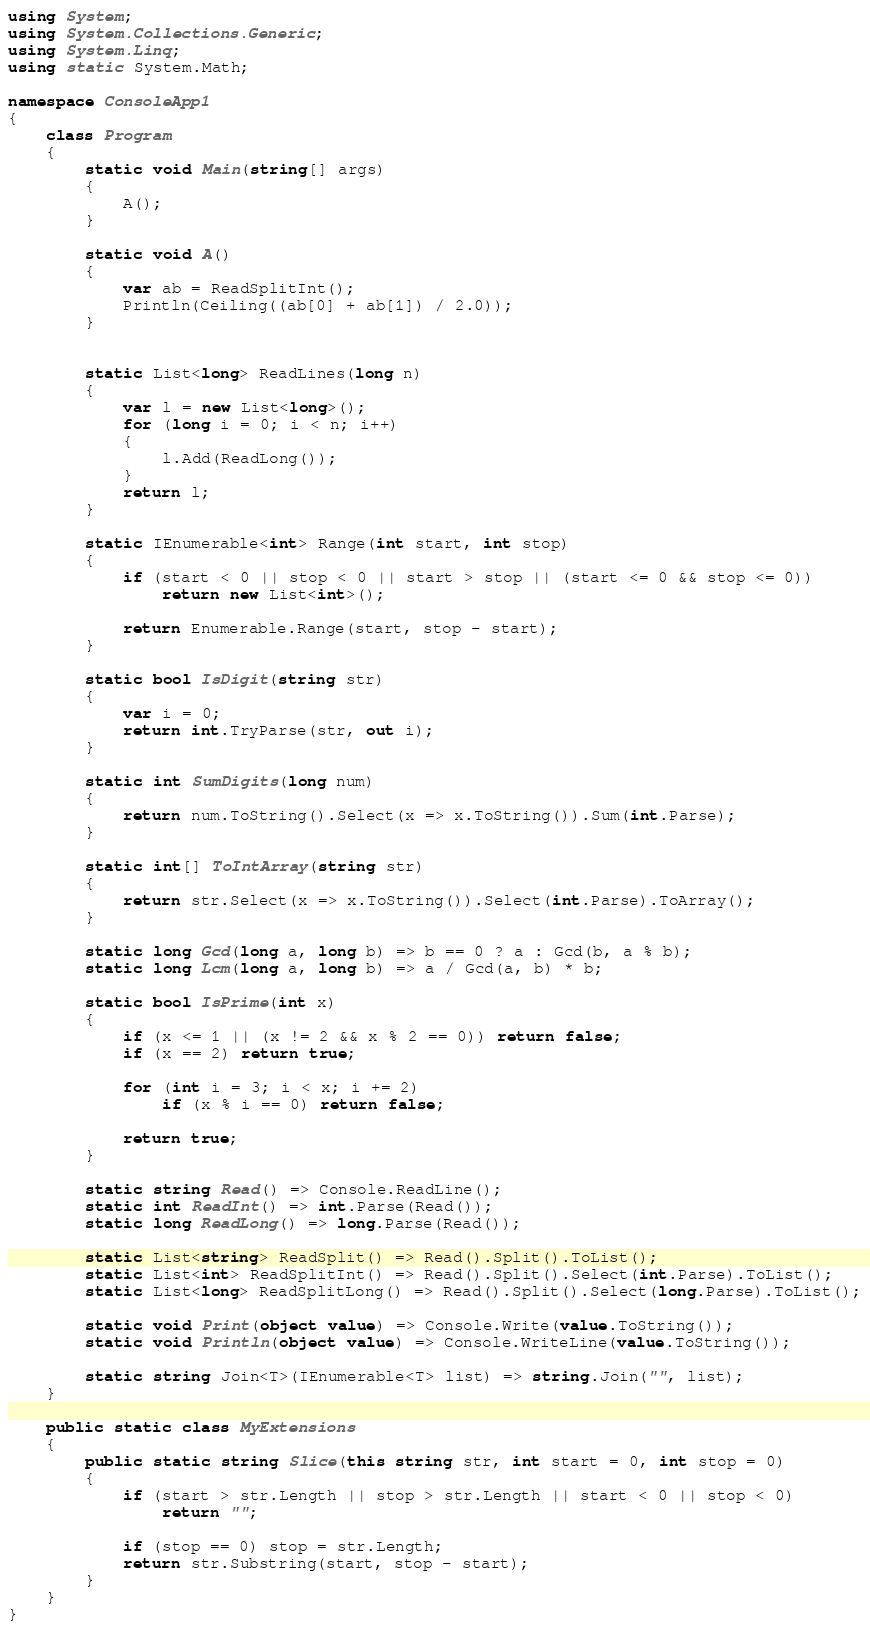<code> <loc_0><loc_0><loc_500><loc_500><_C#_>using System;
using System.Collections.Generic;
using System.Linq;
using static System.Math;

namespace ConsoleApp1
{
    class Program
    {
        static void Main(string[] args)
        {
            A();
        }

        static void A()
        {
            var ab = ReadSplitInt();
            Println(Ceiling((ab[0] + ab[1]) / 2.0));
        }


        static List<long> ReadLines(long n)
        {
            var l = new List<long>();
            for (long i = 0; i < n; i++)
            {
                l.Add(ReadLong());
            }
            return l;
        }

        static IEnumerable<int> Range(int start, int stop)
        {
            if (start < 0 || stop < 0 || start > stop || (start <= 0 && stop <= 0))
                return new List<int>();

            return Enumerable.Range(start, stop - start);
        }

        static bool IsDigit(string str)
        {
            var i = 0;
            return int.TryParse(str, out i);
        }

        static int SumDigits(long num)
        {
            return num.ToString().Select(x => x.ToString()).Sum(int.Parse);
        }

        static int[] ToIntArray(string str)
        {
            return str.Select(x => x.ToString()).Select(int.Parse).ToArray();
        }

        static long Gcd(long a, long b) => b == 0 ? a : Gcd(b, a % b);
        static long Lcm(long a, long b) => a / Gcd(a, b) * b;

        static bool IsPrime(int x)
        {
            if (x <= 1 || (x != 2 && x % 2 == 0)) return false;
            if (x == 2) return true;

            for (int i = 3; i < x; i += 2)
                if (x % i == 0) return false;

            return true;
        }

        static string Read() => Console.ReadLine();
        static int ReadInt() => int.Parse(Read());
        static long ReadLong() => long.Parse(Read());

        static List<string> ReadSplit() => Read().Split().ToList();
        static List<int> ReadSplitInt() => Read().Split().Select(int.Parse).ToList();
        static List<long> ReadSplitLong() => Read().Split().Select(long.Parse).ToList();

        static void Print(object value) => Console.Write(value.ToString());
        static void Println(object value) => Console.WriteLine(value.ToString());

        static string Join<T>(IEnumerable<T> list) => string.Join("", list);
    }

    public static class MyExtensions
    {
        public static string Slice(this string str, int start = 0, int stop = 0)
        {
            if (start > str.Length || stop > str.Length || start < 0 || stop < 0)
                return "";

            if (stop == 0) stop = str.Length;
            return str.Substring(start, stop - start);
        }
    }
}
</code> 